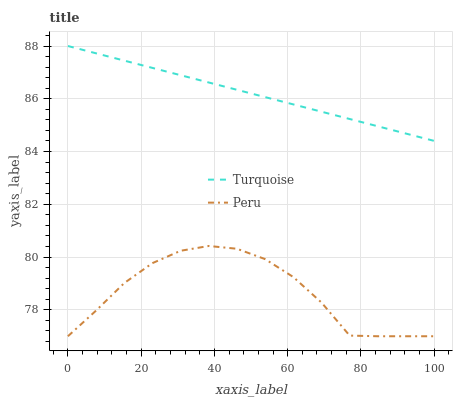Does Peru have the minimum area under the curve?
Answer yes or no. Yes. Does Turquoise have the maximum area under the curve?
Answer yes or no. Yes. Does Peru have the maximum area under the curve?
Answer yes or no. No. Is Turquoise the smoothest?
Answer yes or no. Yes. Is Peru the roughest?
Answer yes or no. Yes. Is Peru the smoothest?
Answer yes or no. No. Does Turquoise have the highest value?
Answer yes or no. Yes. Does Peru have the highest value?
Answer yes or no. No. Is Peru less than Turquoise?
Answer yes or no. Yes. Is Turquoise greater than Peru?
Answer yes or no. Yes. Does Peru intersect Turquoise?
Answer yes or no. No. 